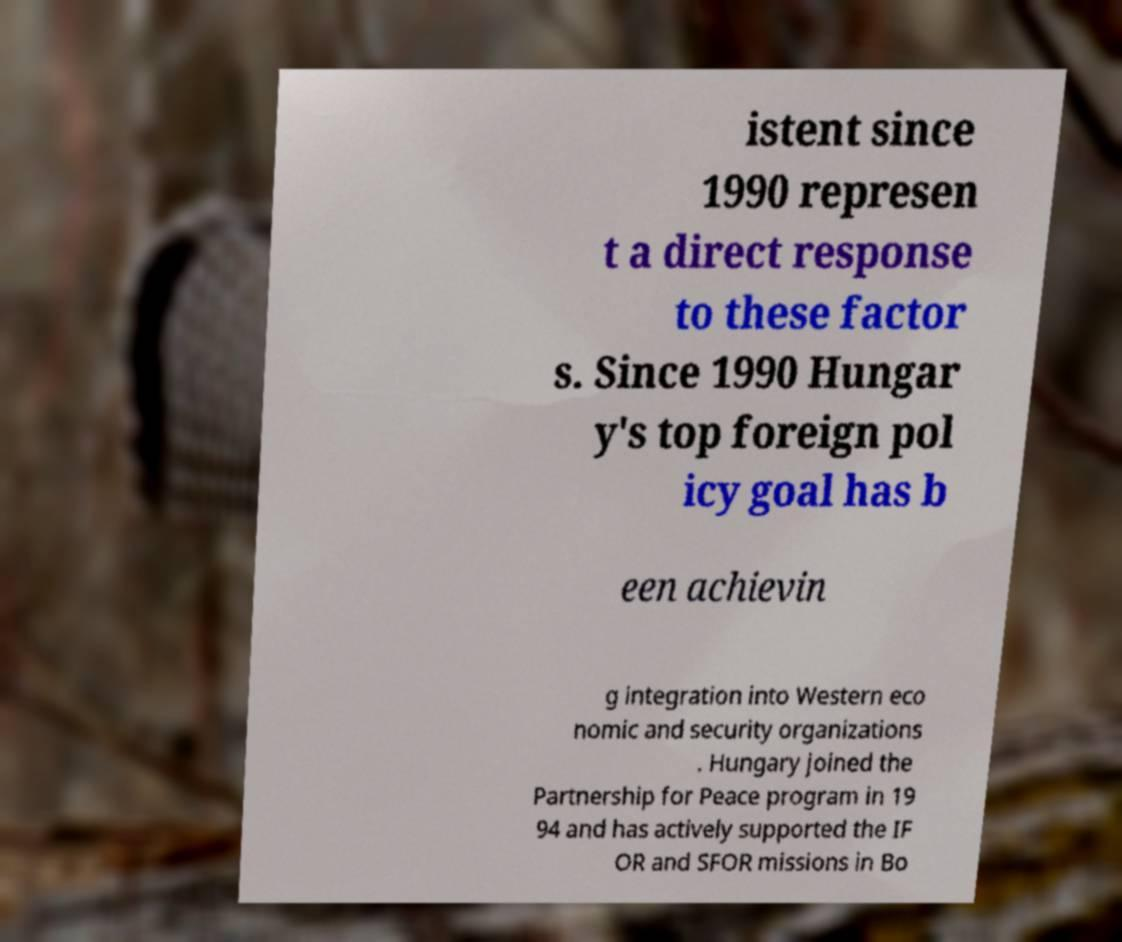I need the written content from this picture converted into text. Can you do that? istent since 1990 represen t a direct response to these factor s. Since 1990 Hungar y's top foreign pol icy goal has b een achievin g integration into Western eco nomic and security organizations . Hungary joined the Partnership for Peace program in 19 94 and has actively supported the IF OR and SFOR missions in Bo 